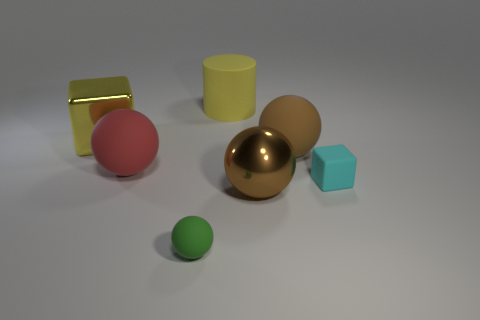Are there an equal number of cylinders in front of the green object and large cyan spheres?
Your answer should be very brief. Yes. There is a big brown thing behind the big sphere that is on the left side of the object that is behind the big shiny block; what is it made of?
Give a very brief answer. Rubber. What material is the other sphere that is the same color as the large metal sphere?
Provide a succinct answer. Rubber. What number of things are either big things that are in front of the red thing or big cyan rubber spheres?
Your answer should be compact. 1. How many objects are either big green balls or balls to the right of the brown shiny ball?
Ensure brevity in your answer.  1. How many big yellow cylinders are on the right side of the tiny object to the right of the yellow matte object on the right side of the green matte ball?
Make the answer very short. 0. There is a cylinder that is the same size as the shiny ball; what is it made of?
Offer a terse response. Rubber. Are there any yellow matte balls of the same size as the cyan matte block?
Make the answer very short. No. What color is the large cube?
Provide a succinct answer. Yellow. The large ball in front of the tiny matte thing that is behind the metallic sphere is what color?
Make the answer very short. Brown. 